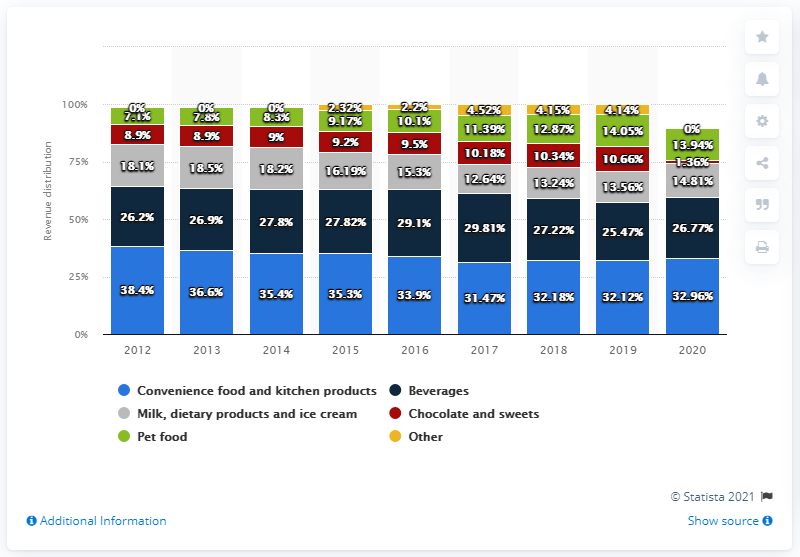Highlight a few significant elements in this photo. The highest and lowest revenue distribution of beverages is 4.34. In 2014, the percentage value of revenue distribution for pet food was 8.3%. 